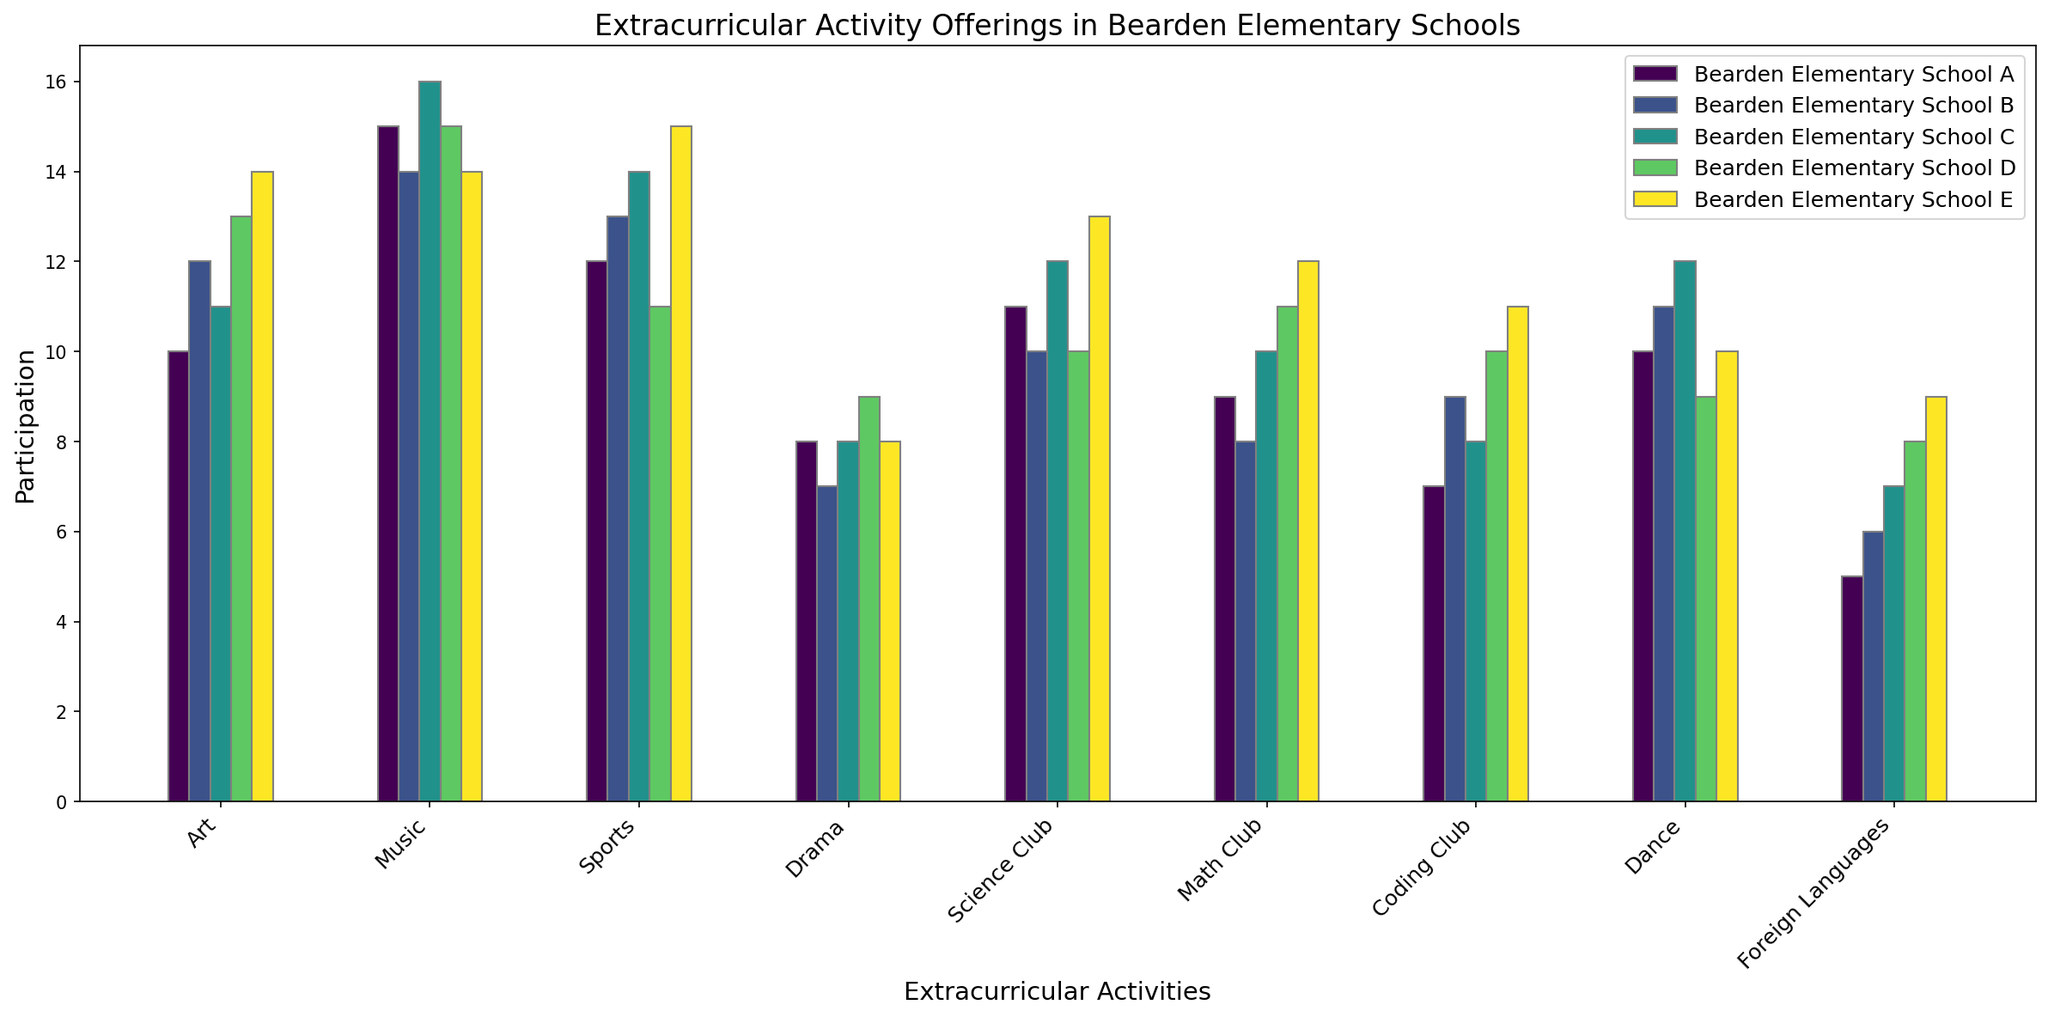Which school has the highest participation in Art? Examine the heights of the bars for the "Art" category and identify the tallest one associated with the school.
Answer: Bearden Elementary School E How many total extracurricular activities does Bearden Elementary School D offer? Sum the participation values across all categories for Bearden Elementary School D: 13 + 15 + 11 + 9 + 10 + 11 + 10 + 9 + 8
Answer: 96 Which extracurricular activity is most popular in Bearden Elementary School C? Identify the category with the tallest bar for Bearden Elementary School C.
Answer: Music What is the difference in participation between Art and Science Club in Bearden Elementary School A? Subtract the participation value of Science Club from the participation value of Art for Bearden Elementary School A: 10 - 11
Answer: -1 Which school offers the highest participation in Coding Club? Examine the lengths of the bars for the "Coding Club" category and identify the tallest one associated with the school.
Answer: Bearden Elementary School E What is the average participation in Sports across all schools? Sum the participation values for Sports for all schools and divide by the number of schools: (12 + 13 + 14 + 11 + 15) / 5
Answer: 13 How do the participation numbers in Drama compare between Bearden Elementary School B and Bearden Elementary School D? Compare the participation values for Drama: Bearden Elementary School B has 7, and Bearden Elementary School D has 9
Answer: Bearden Elementary School D has higher participation Which school has the lowest participation in Foreign Languages? Examine the lengths of the bars for the "Foreign Languages" category and identify the shortest one associated with the school.
Answer: Bearden Elementary School A What is the total participation in Math Club across all schools? Sum the participation values for Math Club across all schools: 9 + 8 + 10 + 11 + 12
Answer: 50 What is the range of participation values in Music across all schools? Find the maximum and minimum participation values for Music and subtract the minimum from the maximum: 16 - 14
Answer: 2 